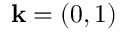<formula> <loc_0><loc_0><loc_500><loc_500>k = ( 0 , 1 )</formula> 